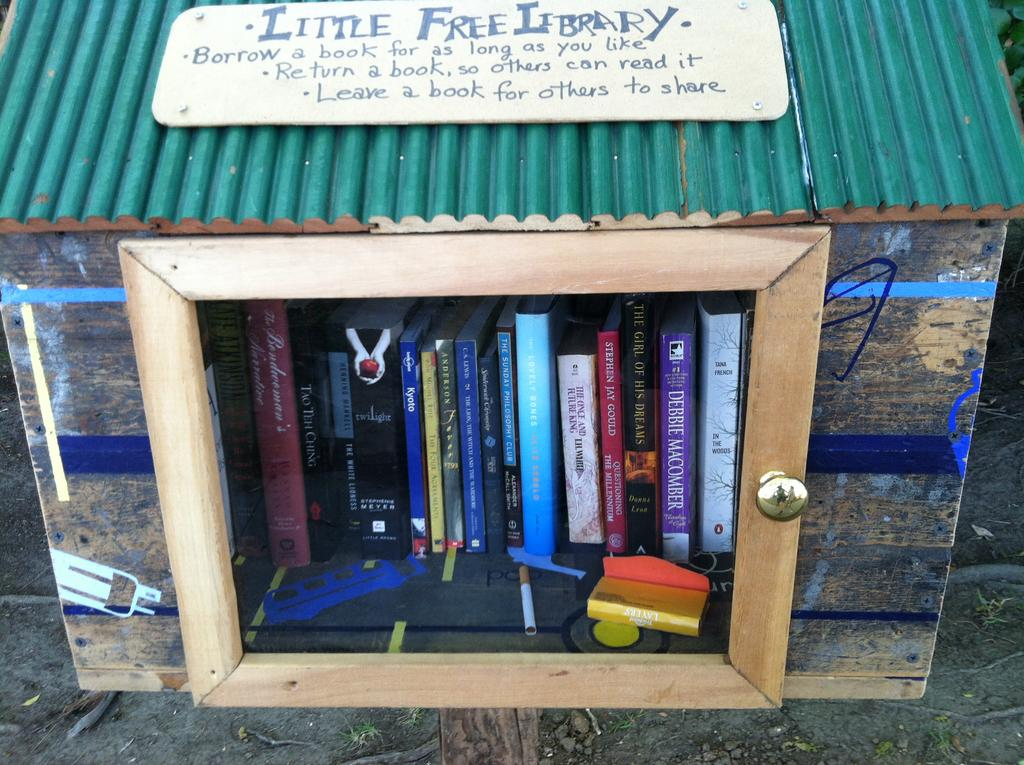<image>
Offer a succinct explanation of the picture presented. You can borrow books at any time from the Little Free Library. 